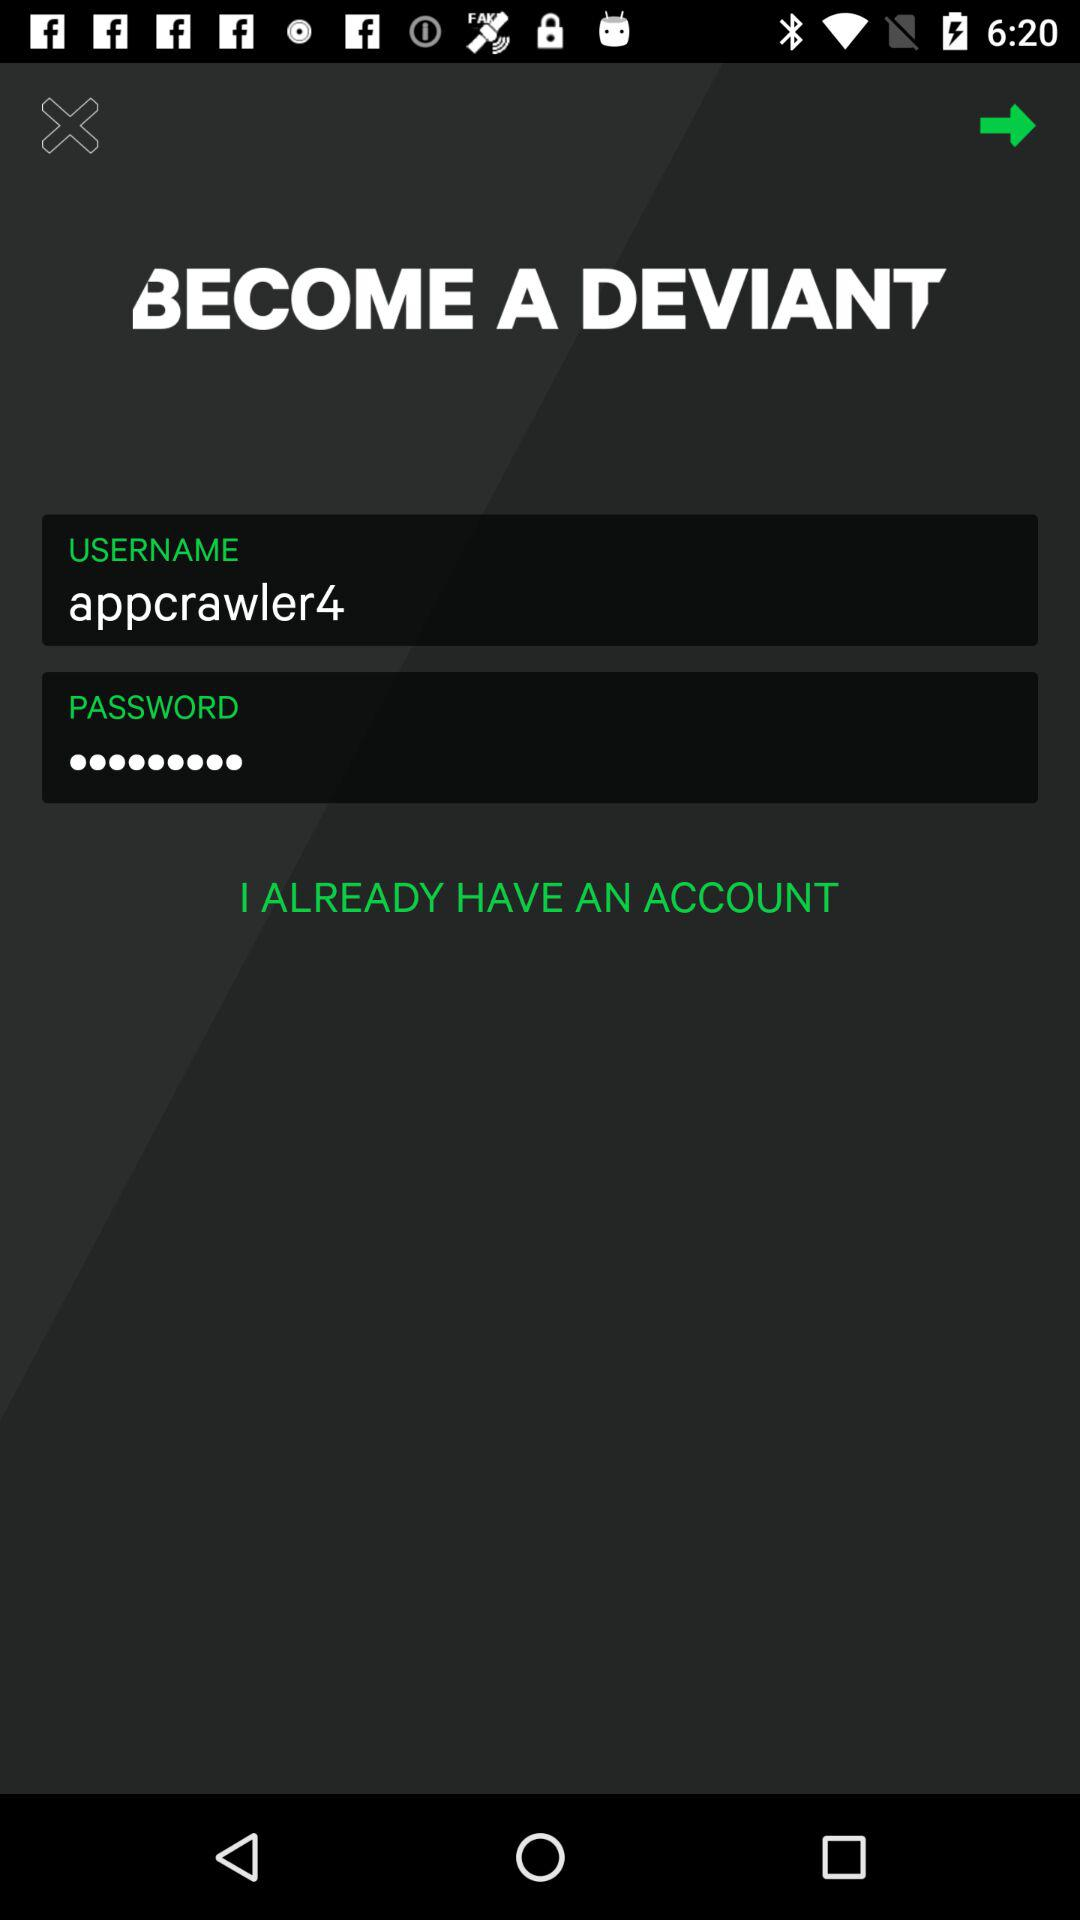What is the username? The username is "appcrawler4". 